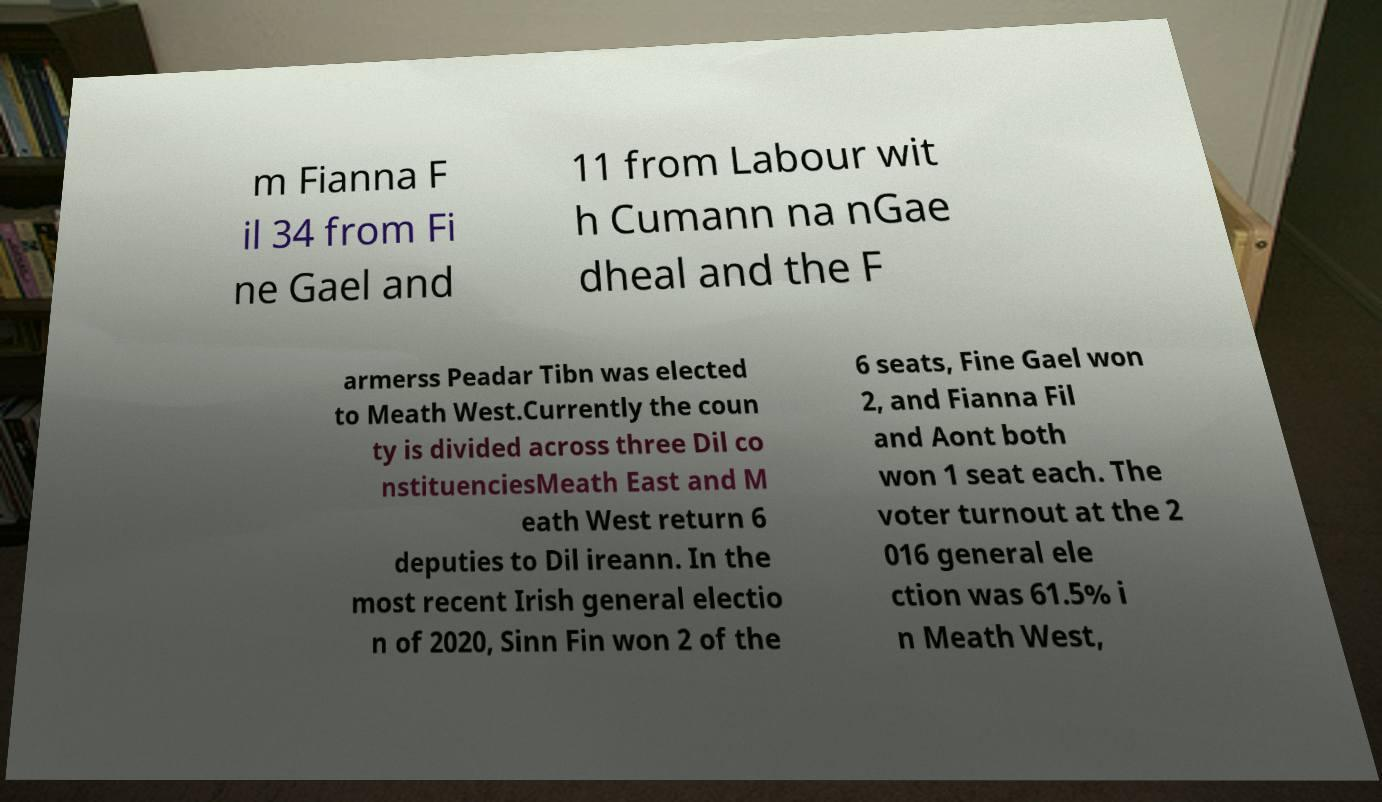Please identify and transcribe the text found in this image. m Fianna F il 34 from Fi ne Gael and 11 from Labour wit h Cumann na nGae dheal and the F armerss Peadar Tibn was elected to Meath West.Currently the coun ty is divided across three Dil co nstituenciesMeath East and M eath West return 6 deputies to Dil ireann. In the most recent Irish general electio n of 2020, Sinn Fin won 2 of the 6 seats, Fine Gael won 2, and Fianna Fil and Aont both won 1 seat each. The voter turnout at the 2 016 general ele ction was 61.5% i n Meath West, 